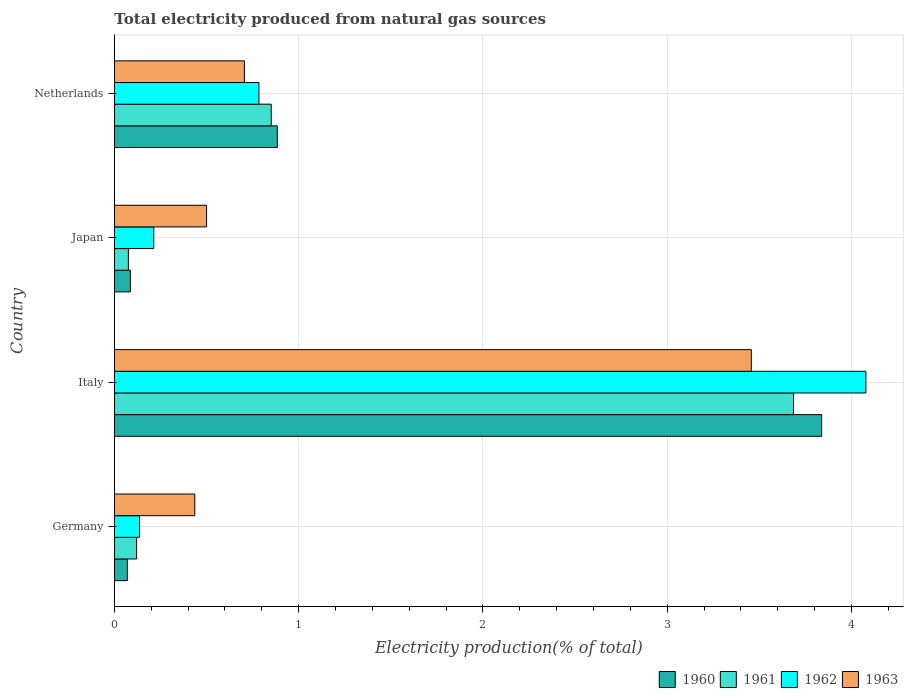How many different coloured bars are there?
Keep it short and to the point. 4. Are the number of bars per tick equal to the number of legend labels?
Offer a very short reply. Yes. How many bars are there on the 2nd tick from the bottom?
Ensure brevity in your answer.  4. What is the label of the 3rd group of bars from the top?
Your answer should be compact. Italy. In how many cases, is the number of bars for a given country not equal to the number of legend labels?
Ensure brevity in your answer.  0. What is the total electricity produced in 1963 in Japan?
Provide a succinct answer. 0.5. Across all countries, what is the maximum total electricity produced in 1963?
Ensure brevity in your answer.  3.46. Across all countries, what is the minimum total electricity produced in 1963?
Your answer should be very brief. 0.44. What is the total total electricity produced in 1963 in the graph?
Make the answer very short. 5.1. What is the difference between the total electricity produced in 1962 in Germany and that in Japan?
Your answer should be compact. -0.08. What is the difference between the total electricity produced in 1962 in Germany and the total electricity produced in 1960 in Netherlands?
Your response must be concise. -0.75. What is the average total electricity produced in 1960 per country?
Ensure brevity in your answer.  1.22. What is the difference between the total electricity produced in 1963 and total electricity produced in 1960 in Italy?
Provide a short and direct response. -0.38. In how many countries, is the total electricity produced in 1963 greater than 2.4 %?
Ensure brevity in your answer.  1. What is the ratio of the total electricity produced in 1962 in Italy to that in Japan?
Ensure brevity in your answer.  19.09. Is the difference between the total electricity produced in 1963 in Italy and Japan greater than the difference between the total electricity produced in 1960 in Italy and Japan?
Provide a short and direct response. No. What is the difference between the highest and the second highest total electricity produced in 1961?
Provide a short and direct response. 2.83. What is the difference between the highest and the lowest total electricity produced in 1960?
Ensure brevity in your answer.  3.77. Is the sum of the total electricity produced in 1962 in Italy and Netherlands greater than the maximum total electricity produced in 1960 across all countries?
Provide a short and direct response. Yes. What does the 1st bar from the bottom in Netherlands represents?
Keep it short and to the point. 1960. Are all the bars in the graph horizontal?
Provide a short and direct response. Yes. How many countries are there in the graph?
Keep it short and to the point. 4. What is the difference between two consecutive major ticks on the X-axis?
Provide a short and direct response. 1. Does the graph contain any zero values?
Give a very brief answer. No. Does the graph contain grids?
Offer a terse response. Yes. Where does the legend appear in the graph?
Provide a succinct answer. Bottom right. How many legend labels are there?
Give a very brief answer. 4. What is the title of the graph?
Offer a very short reply. Total electricity produced from natural gas sources. What is the label or title of the X-axis?
Provide a succinct answer. Electricity production(% of total). What is the label or title of the Y-axis?
Your answer should be very brief. Country. What is the Electricity production(% of total) of 1960 in Germany?
Offer a very short reply. 0.07. What is the Electricity production(% of total) in 1961 in Germany?
Ensure brevity in your answer.  0.12. What is the Electricity production(% of total) in 1962 in Germany?
Give a very brief answer. 0.14. What is the Electricity production(% of total) in 1963 in Germany?
Offer a terse response. 0.44. What is the Electricity production(% of total) in 1960 in Italy?
Provide a short and direct response. 3.84. What is the Electricity production(% of total) of 1961 in Italy?
Your response must be concise. 3.69. What is the Electricity production(% of total) in 1962 in Italy?
Your response must be concise. 4.08. What is the Electricity production(% of total) in 1963 in Italy?
Keep it short and to the point. 3.46. What is the Electricity production(% of total) of 1960 in Japan?
Your answer should be compact. 0.09. What is the Electricity production(% of total) in 1961 in Japan?
Offer a very short reply. 0.08. What is the Electricity production(% of total) in 1962 in Japan?
Your answer should be very brief. 0.21. What is the Electricity production(% of total) of 1963 in Japan?
Give a very brief answer. 0.5. What is the Electricity production(% of total) in 1960 in Netherlands?
Provide a succinct answer. 0.88. What is the Electricity production(% of total) in 1961 in Netherlands?
Keep it short and to the point. 0.85. What is the Electricity production(% of total) of 1962 in Netherlands?
Make the answer very short. 0.78. What is the Electricity production(% of total) of 1963 in Netherlands?
Provide a succinct answer. 0.71. Across all countries, what is the maximum Electricity production(% of total) of 1960?
Your response must be concise. 3.84. Across all countries, what is the maximum Electricity production(% of total) of 1961?
Offer a very short reply. 3.69. Across all countries, what is the maximum Electricity production(% of total) of 1962?
Offer a terse response. 4.08. Across all countries, what is the maximum Electricity production(% of total) of 1963?
Ensure brevity in your answer.  3.46. Across all countries, what is the minimum Electricity production(% of total) in 1960?
Ensure brevity in your answer.  0.07. Across all countries, what is the minimum Electricity production(% of total) in 1961?
Offer a very short reply. 0.08. Across all countries, what is the minimum Electricity production(% of total) in 1962?
Offer a very short reply. 0.14. Across all countries, what is the minimum Electricity production(% of total) of 1963?
Ensure brevity in your answer.  0.44. What is the total Electricity production(% of total) of 1960 in the graph?
Your answer should be very brief. 4.88. What is the total Electricity production(% of total) of 1961 in the graph?
Your answer should be compact. 4.73. What is the total Electricity production(% of total) of 1962 in the graph?
Offer a terse response. 5.21. What is the total Electricity production(% of total) of 1963 in the graph?
Provide a short and direct response. 5.1. What is the difference between the Electricity production(% of total) of 1960 in Germany and that in Italy?
Your answer should be compact. -3.77. What is the difference between the Electricity production(% of total) in 1961 in Germany and that in Italy?
Offer a very short reply. -3.57. What is the difference between the Electricity production(% of total) of 1962 in Germany and that in Italy?
Your answer should be very brief. -3.94. What is the difference between the Electricity production(% of total) of 1963 in Germany and that in Italy?
Offer a very short reply. -3.02. What is the difference between the Electricity production(% of total) in 1960 in Germany and that in Japan?
Your answer should be compact. -0.02. What is the difference between the Electricity production(% of total) of 1961 in Germany and that in Japan?
Give a very brief answer. 0.04. What is the difference between the Electricity production(% of total) of 1962 in Germany and that in Japan?
Make the answer very short. -0.08. What is the difference between the Electricity production(% of total) of 1963 in Germany and that in Japan?
Your response must be concise. -0.06. What is the difference between the Electricity production(% of total) in 1960 in Germany and that in Netherlands?
Offer a very short reply. -0.81. What is the difference between the Electricity production(% of total) of 1961 in Germany and that in Netherlands?
Make the answer very short. -0.73. What is the difference between the Electricity production(% of total) of 1962 in Germany and that in Netherlands?
Your answer should be very brief. -0.65. What is the difference between the Electricity production(% of total) in 1963 in Germany and that in Netherlands?
Keep it short and to the point. -0.27. What is the difference between the Electricity production(% of total) in 1960 in Italy and that in Japan?
Ensure brevity in your answer.  3.75. What is the difference between the Electricity production(% of total) in 1961 in Italy and that in Japan?
Give a very brief answer. 3.61. What is the difference between the Electricity production(% of total) of 1962 in Italy and that in Japan?
Give a very brief answer. 3.86. What is the difference between the Electricity production(% of total) in 1963 in Italy and that in Japan?
Your response must be concise. 2.96. What is the difference between the Electricity production(% of total) of 1960 in Italy and that in Netherlands?
Your answer should be very brief. 2.95. What is the difference between the Electricity production(% of total) in 1961 in Italy and that in Netherlands?
Offer a terse response. 2.83. What is the difference between the Electricity production(% of total) in 1962 in Italy and that in Netherlands?
Your answer should be very brief. 3.29. What is the difference between the Electricity production(% of total) in 1963 in Italy and that in Netherlands?
Ensure brevity in your answer.  2.75. What is the difference between the Electricity production(% of total) of 1960 in Japan and that in Netherlands?
Give a very brief answer. -0.8. What is the difference between the Electricity production(% of total) of 1961 in Japan and that in Netherlands?
Offer a terse response. -0.78. What is the difference between the Electricity production(% of total) of 1962 in Japan and that in Netherlands?
Give a very brief answer. -0.57. What is the difference between the Electricity production(% of total) in 1963 in Japan and that in Netherlands?
Give a very brief answer. -0.21. What is the difference between the Electricity production(% of total) in 1960 in Germany and the Electricity production(% of total) in 1961 in Italy?
Offer a very short reply. -3.62. What is the difference between the Electricity production(% of total) in 1960 in Germany and the Electricity production(% of total) in 1962 in Italy?
Your answer should be compact. -4.01. What is the difference between the Electricity production(% of total) in 1960 in Germany and the Electricity production(% of total) in 1963 in Italy?
Offer a very short reply. -3.39. What is the difference between the Electricity production(% of total) of 1961 in Germany and the Electricity production(% of total) of 1962 in Italy?
Ensure brevity in your answer.  -3.96. What is the difference between the Electricity production(% of total) in 1961 in Germany and the Electricity production(% of total) in 1963 in Italy?
Provide a succinct answer. -3.34. What is the difference between the Electricity production(% of total) of 1962 in Germany and the Electricity production(% of total) of 1963 in Italy?
Keep it short and to the point. -3.32. What is the difference between the Electricity production(% of total) in 1960 in Germany and the Electricity production(% of total) in 1961 in Japan?
Provide a succinct answer. -0.01. What is the difference between the Electricity production(% of total) of 1960 in Germany and the Electricity production(% of total) of 1962 in Japan?
Ensure brevity in your answer.  -0.14. What is the difference between the Electricity production(% of total) of 1960 in Germany and the Electricity production(% of total) of 1963 in Japan?
Offer a very short reply. -0.43. What is the difference between the Electricity production(% of total) in 1961 in Germany and the Electricity production(% of total) in 1962 in Japan?
Your answer should be compact. -0.09. What is the difference between the Electricity production(% of total) in 1961 in Germany and the Electricity production(% of total) in 1963 in Japan?
Ensure brevity in your answer.  -0.38. What is the difference between the Electricity production(% of total) of 1962 in Germany and the Electricity production(% of total) of 1963 in Japan?
Provide a succinct answer. -0.36. What is the difference between the Electricity production(% of total) of 1960 in Germany and the Electricity production(% of total) of 1961 in Netherlands?
Keep it short and to the point. -0.78. What is the difference between the Electricity production(% of total) in 1960 in Germany and the Electricity production(% of total) in 1962 in Netherlands?
Ensure brevity in your answer.  -0.71. What is the difference between the Electricity production(% of total) in 1960 in Germany and the Electricity production(% of total) in 1963 in Netherlands?
Your answer should be very brief. -0.64. What is the difference between the Electricity production(% of total) of 1961 in Germany and the Electricity production(% of total) of 1962 in Netherlands?
Your answer should be compact. -0.66. What is the difference between the Electricity production(% of total) in 1961 in Germany and the Electricity production(% of total) in 1963 in Netherlands?
Ensure brevity in your answer.  -0.58. What is the difference between the Electricity production(% of total) of 1962 in Germany and the Electricity production(% of total) of 1963 in Netherlands?
Your response must be concise. -0.57. What is the difference between the Electricity production(% of total) of 1960 in Italy and the Electricity production(% of total) of 1961 in Japan?
Keep it short and to the point. 3.76. What is the difference between the Electricity production(% of total) of 1960 in Italy and the Electricity production(% of total) of 1962 in Japan?
Your answer should be very brief. 3.62. What is the difference between the Electricity production(% of total) of 1960 in Italy and the Electricity production(% of total) of 1963 in Japan?
Provide a succinct answer. 3.34. What is the difference between the Electricity production(% of total) in 1961 in Italy and the Electricity production(% of total) in 1962 in Japan?
Offer a very short reply. 3.47. What is the difference between the Electricity production(% of total) in 1961 in Italy and the Electricity production(% of total) in 1963 in Japan?
Provide a short and direct response. 3.19. What is the difference between the Electricity production(% of total) in 1962 in Italy and the Electricity production(% of total) in 1963 in Japan?
Keep it short and to the point. 3.58. What is the difference between the Electricity production(% of total) of 1960 in Italy and the Electricity production(% of total) of 1961 in Netherlands?
Your response must be concise. 2.99. What is the difference between the Electricity production(% of total) in 1960 in Italy and the Electricity production(% of total) in 1962 in Netherlands?
Ensure brevity in your answer.  3.05. What is the difference between the Electricity production(% of total) in 1960 in Italy and the Electricity production(% of total) in 1963 in Netherlands?
Your answer should be very brief. 3.13. What is the difference between the Electricity production(% of total) in 1961 in Italy and the Electricity production(% of total) in 1962 in Netherlands?
Give a very brief answer. 2.9. What is the difference between the Electricity production(% of total) in 1961 in Italy and the Electricity production(% of total) in 1963 in Netherlands?
Keep it short and to the point. 2.98. What is the difference between the Electricity production(% of total) in 1962 in Italy and the Electricity production(% of total) in 1963 in Netherlands?
Offer a very short reply. 3.37. What is the difference between the Electricity production(% of total) in 1960 in Japan and the Electricity production(% of total) in 1961 in Netherlands?
Offer a terse response. -0.76. What is the difference between the Electricity production(% of total) in 1960 in Japan and the Electricity production(% of total) in 1962 in Netherlands?
Offer a terse response. -0.7. What is the difference between the Electricity production(% of total) in 1960 in Japan and the Electricity production(% of total) in 1963 in Netherlands?
Give a very brief answer. -0.62. What is the difference between the Electricity production(% of total) of 1961 in Japan and the Electricity production(% of total) of 1962 in Netherlands?
Your response must be concise. -0.71. What is the difference between the Electricity production(% of total) of 1961 in Japan and the Electricity production(% of total) of 1963 in Netherlands?
Provide a short and direct response. -0.63. What is the difference between the Electricity production(% of total) in 1962 in Japan and the Electricity production(% of total) in 1963 in Netherlands?
Provide a succinct answer. -0.49. What is the average Electricity production(% of total) in 1960 per country?
Make the answer very short. 1.22. What is the average Electricity production(% of total) in 1961 per country?
Your answer should be very brief. 1.18. What is the average Electricity production(% of total) in 1962 per country?
Provide a short and direct response. 1.3. What is the average Electricity production(% of total) in 1963 per country?
Offer a very short reply. 1.27. What is the difference between the Electricity production(% of total) of 1960 and Electricity production(% of total) of 1961 in Germany?
Your answer should be compact. -0.05. What is the difference between the Electricity production(% of total) of 1960 and Electricity production(% of total) of 1962 in Germany?
Provide a succinct answer. -0.07. What is the difference between the Electricity production(% of total) of 1960 and Electricity production(% of total) of 1963 in Germany?
Your answer should be compact. -0.37. What is the difference between the Electricity production(% of total) in 1961 and Electricity production(% of total) in 1962 in Germany?
Offer a terse response. -0.02. What is the difference between the Electricity production(% of total) of 1961 and Electricity production(% of total) of 1963 in Germany?
Your answer should be compact. -0.32. What is the difference between the Electricity production(% of total) of 1962 and Electricity production(% of total) of 1963 in Germany?
Offer a very short reply. -0.3. What is the difference between the Electricity production(% of total) in 1960 and Electricity production(% of total) in 1961 in Italy?
Offer a terse response. 0.15. What is the difference between the Electricity production(% of total) of 1960 and Electricity production(% of total) of 1962 in Italy?
Your answer should be compact. -0.24. What is the difference between the Electricity production(% of total) of 1960 and Electricity production(% of total) of 1963 in Italy?
Your answer should be very brief. 0.38. What is the difference between the Electricity production(% of total) in 1961 and Electricity production(% of total) in 1962 in Italy?
Your response must be concise. -0.39. What is the difference between the Electricity production(% of total) of 1961 and Electricity production(% of total) of 1963 in Italy?
Provide a succinct answer. 0.23. What is the difference between the Electricity production(% of total) of 1962 and Electricity production(% of total) of 1963 in Italy?
Provide a short and direct response. 0.62. What is the difference between the Electricity production(% of total) in 1960 and Electricity production(% of total) in 1961 in Japan?
Make the answer very short. 0.01. What is the difference between the Electricity production(% of total) of 1960 and Electricity production(% of total) of 1962 in Japan?
Make the answer very short. -0.13. What is the difference between the Electricity production(% of total) in 1960 and Electricity production(% of total) in 1963 in Japan?
Keep it short and to the point. -0.41. What is the difference between the Electricity production(% of total) of 1961 and Electricity production(% of total) of 1962 in Japan?
Your answer should be very brief. -0.14. What is the difference between the Electricity production(% of total) in 1961 and Electricity production(% of total) in 1963 in Japan?
Make the answer very short. -0.42. What is the difference between the Electricity production(% of total) of 1962 and Electricity production(% of total) of 1963 in Japan?
Your answer should be compact. -0.29. What is the difference between the Electricity production(% of total) of 1960 and Electricity production(% of total) of 1961 in Netherlands?
Your response must be concise. 0.03. What is the difference between the Electricity production(% of total) in 1960 and Electricity production(% of total) in 1962 in Netherlands?
Give a very brief answer. 0.1. What is the difference between the Electricity production(% of total) in 1960 and Electricity production(% of total) in 1963 in Netherlands?
Ensure brevity in your answer.  0.18. What is the difference between the Electricity production(% of total) in 1961 and Electricity production(% of total) in 1962 in Netherlands?
Offer a very short reply. 0.07. What is the difference between the Electricity production(% of total) in 1961 and Electricity production(% of total) in 1963 in Netherlands?
Keep it short and to the point. 0.15. What is the difference between the Electricity production(% of total) in 1962 and Electricity production(% of total) in 1963 in Netherlands?
Provide a short and direct response. 0.08. What is the ratio of the Electricity production(% of total) of 1960 in Germany to that in Italy?
Your answer should be very brief. 0.02. What is the ratio of the Electricity production(% of total) in 1961 in Germany to that in Italy?
Your response must be concise. 0.03. What is the ratio of the Electricity production(% of total) of 1962 in Germany to that in Italy?
Keep it short and to the point. 0.03. What is the ratio of the Electricity production(% of total) in 1963 in Germany to that in Italy?
Your answer should be compact. 0.13. What is the ratio of the Electricity production(% of total) of 1960 in Germany to that in Japan?
Offer a very short reply. 0.81. What is the ratio of the Electricity production(% of total) of 1961 in Germany to that in Japan?
Provide a succinct answer. 1.59. What is the ratio of the Electricity production(% of total) in 1962 in Germany to that in Japan?
Your response must be concise. 0.64. What is the ratio of the Electricity production(% of total) of 1963 in Germany to that in Japan?
Provide a short and direct response. 0.87. What is the ratio of the Electricity production(% of total) in 1960 in Germany to that in Netherlands?
Keep it short and to the point. 0.08. What is the ratio of the Electricity production(% of total) of 1961 in Germany to that in Netherlands?
Your answer should be very brief. 0.14. What is the ratio of the Electricity production(% of total) in 1962 in Germany to that in Netherlands?
Keep it short and to the point. 0.17. What is the ratio of the Electricity production(% of total) of 1963 in Germany to that in Netherlands?
Keep it short and to the point. 0.62. What is the ratio of the Electricity production(% of total) in 1960 in Italy to that in Japan?
Ensure brevity in your answer.  44.33. What is the ratio of the Electricity production(% of total) of 1961 in Italy to that in Japan?
Your response must be concise. 48.69. What is the ratio of the Electricity production(% of total) in 1962 in Italy to that in Japan?
Provide a short and direct response. 19.09. What is the ratio of the Electricity production(% of total) in 1963 in Italy to that in Japan?
Your answer should be very brief. 6.91. What is the ratio of the Electricity production(% of total) in 1960 in Italy to that in Netherlands?
Keep it short and to the point. 4.34. What is the ratio of the Electricity production(% of total) of 1961 in Italy to that in Netherlands?
Your response must be concise. 4.33. What is the ratio of the Electricity production(% of total) of 1962 in Italy to that in Netherlands?
Your answer should be compact. 5.2. What is the ratio of the Electricity production(% of total) in 1963 in Italy to that in Netherlands?
Ensure brevity in your answer.  4.9. What is the ratio of the Electricity production(% of total) in 1960 in Japan to that in Netherlands?
Give a very brief answer. 0.1. What is the ratio of the Electricity production(% of total) in 1961 in Japan to that in Netherlands?
Make the answer very short. 0.09. What is the ratio of the Electricity production(% of total) of 1962 in Japan to that in Netherlands?
Ensure brevity in your answer.  0.27. What is the ratio of the Electricity production(% of total) in 1963 in Japan to that in Netherlands?
Your answer should be compact. 0.71. What is the difference between the highest and the second highest Electricity production(% of total) of 1960?
Ensure brevity in your answer.  2.95. What is the difference between the highest and the second highest Electricity production(% of total) of 1961?
Ensure brevity in your answer.  2.83. What is the difference between the highest and the second highest Electricity production(% of total) of 1962?
Keep it short and to the point. 3.29. What is the difference between the highest and the second highest Electricity production(% of total) of 1963?
Offer a very short reply. 2.75. What is the difference between the highest and the lowest Electricity production(% of total) of 1960?
Keep it short and to the point. 3.77. What is the difference between the highest and the lowest Electricity production(% of total) in 1961?
Offer a terse response. 3.61. What is the difference between the highest and the lowest Electricity production(% of total) of 1962?
Provide a short and direct response. 3.94. What is the difference between the highest and the lowest Electricity production(% of total) in 1963?
Make the answer very short. 3.02. 